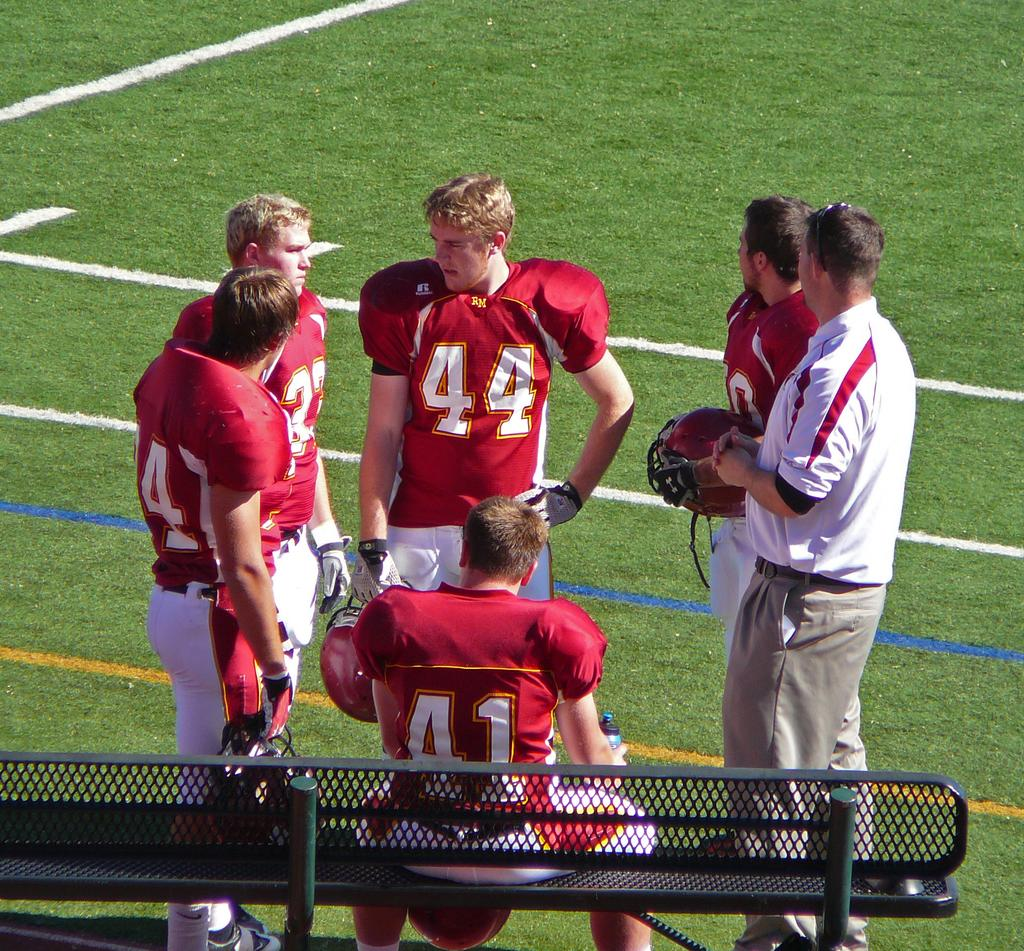How many people are present in the image? There are six people in the image. What are the majority of the people doing in the image? Five of the people are standing. What is the position of the remaining person in the image? One person is sitting on a bench. What type of natural environment can be seen in the background of the image? There is grass visible in the background of the image. Why is the fifth person crying in the image? There is no indication in the image that any of the people are crying, including the fifth person. 